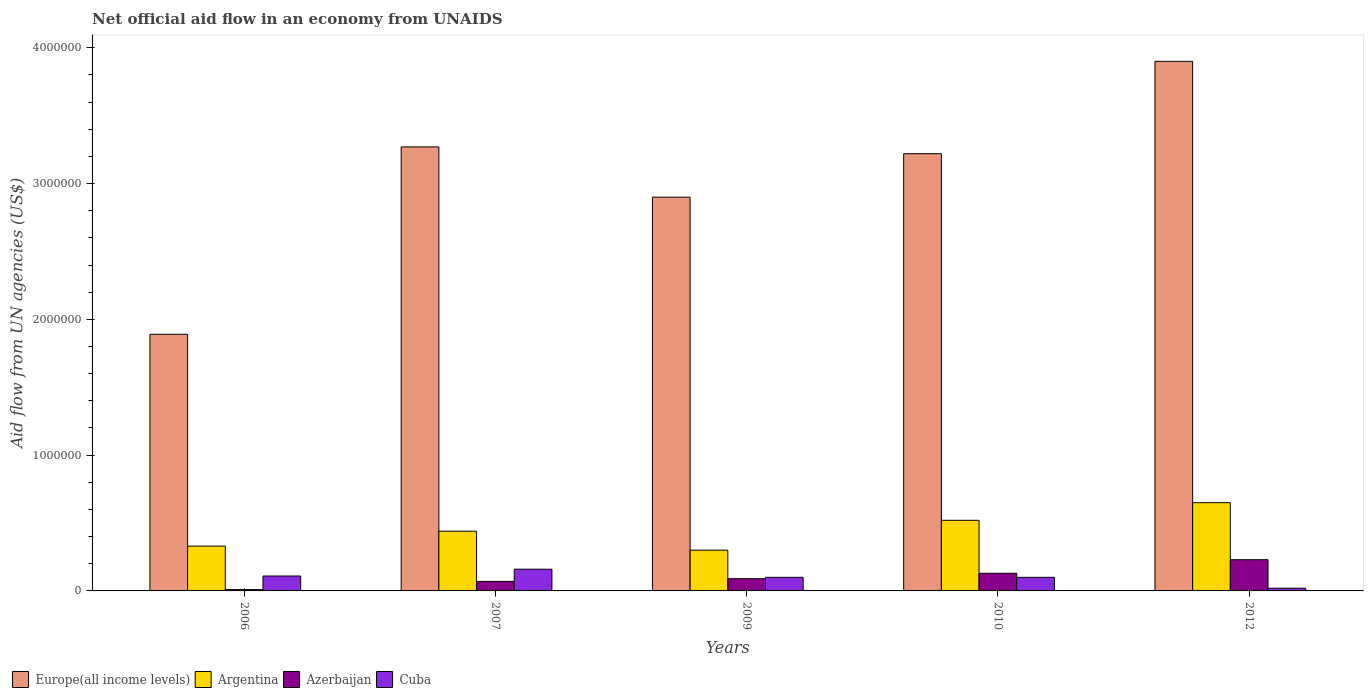How many bars are there on the 1st tick from the left?
Ensure brevity in your answer.  4. What is the net official aid flow in Argentina in 2007?
Ensure brevity in your answer.  4.40e+05. Across all years, what is the maximum net official aid flow in Azerbaijan?
Give a very brief answer. 2.30e+05. What is the total net official aid flow in Argentina in the graph?
Provide a succinct answer. 2.24e+06. What is the difference between the net official aid flow in Cuba in 2006 and that in 2009?
Provide a succinct answer. 10000. What is the difference between the net official aid flow in Argentina in 2009 and the net official aid flow in Europe(all income levels) in 2006?
Make the answer very short. -1.59e+06. What is the average net official aid flow in Cuba per year?
Your response must be concise. 9.80e+04. In the year 2007, what is the difference between the net official aid flow in Argentina and net official aid flow in Europe(all income levels)?
Ensure brevity in your answer.  -2.83e+06. In how many years, is the net official aid flow in Azerbaijan greater than 3400000 US$?
Keep it short and to the point. 0. What is the ratio of the net official aid flow in Azerbaijan in 2007 to that in 2010?
Provide a succinct answer. 0.54. Is the net official aid flow in Cuba in 2006 less than that in 2012?
Make the answer very short. No. Is the difference between the net official aid flow in Argentina in 2009 and 2012 greater than the difference between the net official aid flow in Europe(all income levels) in 2009 and 2012?
Ensure brevity in your answer.  Yes. What is the difference between the highest and the second highest net official aid flow in Azerbaijan?
Provide a short and direct response. 1.00e+05. What is the difference between the highest and the lowest net official aid flow in Europe(all income levels)?
Ensure brevity in your answer.  2.01e+06. Is it the case that in every year, the sum of the net official aid flow in Argentina and net official aid flow in Cuba is greater than the sum of net official aid flow in Europe(all income levels) and net official aid flow in Azerbaijan?
Your answer should be compact. No. What does the 2nd bar from the left in 2009 represents?
Provide a succinct answer. Argentina. What does the 4th bar from the right in 2009 represents?
Make the answer very short. Europe(all income levels). What is the difference between two consecutive major ticks on the Y-axis?
Give a very brief answer. 1.00e+06. How are the legend labels stacked?
Provide a short and direct response. Horizontal. What is the title of the graph?
Make the answer very short. Net official aid flow in an economy from UNAIDS. What is the label or title of the Y-axis?
Provide a short and direct response. Aid flow from UN agencies (US$). What is the Aid flow from UN agencies (US$) of Europe(all income levels) in 2006?
Provide a short and direct response. 1.89e+06. What is the Aid flow from UN agencies (US$) of Argentina in 2006?
Keep it short and to the point. 3.30e+05. What is the Aid flow from UN agencies (US$) of Cuba in 2006?
Ensure brevity in your answer.  1.10e+05. What is the Aid flow from UN agencies (US$) of Europe(all income levels) in 2007?
Your answer should be compact. 3.27e+06. What is the Aid flow from UN agencies (US$) of Argentina in 2007?
Offer a very short reply. 4.40e+05. What is the Aid flow from UN agencies (US$) in Cuba in 2007?
Give a very brief answer. 1.60e+05. What is the Aid flow from UN agencies (US$) of Europe(all income levels) in 2009?
Give a very brief answer. 2.90e+06. What is the Aid flow from UN agencies (US$) in Europe(all income levels) in 2010?
Give a very brief answer. 3.22e+06. What is the Aid flow from UN agencies (US$) in Argentina in 2010?
Provide a succinct answer. 5.20e+05. What is the Aid flow from UN agencies (US$) in Azerbaijan in 2010?
Offer a very short reply. 1.30e+05. What is the Aid flow from UN agencies (US$) of Europe(all income levels) in 2012?
Your answer should be very brief. 3.90e+06. What is the Aid flow from UN agencies (US$) of Argentina in 2012?
Ensure brevity in your answer.  6.50e+05. What is the Aid flow from UN agencies (US$) of Cuba in 2012?
Provide a succinct answer. 2.00e+04. Across all years, what is the maximum Aid flow from UN agencies (US$) in Europe(all income levels)?
Provide a short and direct response. 3.90e+06. Across all years, what is the maximum Aid flow from UN agencies (US$) of Argentina?
Make the answer very short. 6.50e+05. Across all years, what is the maximum Aid flow from UN agencies (US$) of Azerbaijan?
Keep it short and to the point. 2.30e+05. Across all years, what is the minimum Aid flow from UN agencies (US$) in Europe(all income levels)?
Offer a terse response. 1.89e+06. Across all years, what is the minimum Aid flow from UN agencies (US$) in Argentina?
Keep it short and to the point. 3.00e+05. Across all years, what is the minimum Aid flow from UN agencies (US$) of Azerbaijan?
Your answer should be very brief. 10000. Across all years, what is the minimum Aid flow from UN agencies (US$) of Cuba?
Give a very brief answer. 2.00e+04. What is the total Aid flow from UN agencies (US$) in Europe(all income levels) in the graph?
Give a very brief answer. 1.52e+07. What is the total Aid flow from UN agencies (US$) of Argentina in the graph?
Give a very brief answer. 2.24e+06. What is the total Aid flow from UN agencies (US$) in Azerbaijan in the graph?
Provide a short and direct response. 5.30e+05. What is the total Aid flow from UN agencies (US$) of Cuba in the graph?
Ensure brevity in your answer.  4.90e+05. What is the difference between the Aid flow from UN agencies (US$) in Europe(all income levels) in 2006 and that in 2007?
Provide a succinct answer. -1.38e+06. What is the difference between the Aid flow from UN agencies (US$) of Argentina in 2006 and that in 2007?
Provide a short and direct response. -1.10e+05. What is the difference between the Aid flow from UN agencies (US$) of Europe(all income levels) in 2006 and that in 2009?
Give a very brief answer. -1.01e+06. What is the difference between the Aid flow from UN agencies (US$) of Europe(all income levels) in 2006 and that in 2010?
Keep it short and to the point. -1.33e+06. What is the difference between the Aid flow from UN agencies (US$) of Azerbaijan in 2006 and that in 2010?
Your response must be concise. -1.20e+05. What is the difference between the Aid flow from UN agencies (US$) in Cuba in 2006 and that in 2010?
Provide a succinct answer. 10000. What is the difference between the Aid flow from UN agencies (US$) in Europe(all income levels) in 2006 and that in 2012?
Offer a terse response. -2.01e+06. What is the difference between the Aid flow from UN agencies (US$) of Argentina in 2006 and that in 2012?
Your answer should be compact. -3.20e+05. What is the difference between the Aid flow from UN agencies (US$) in Azerbaijan in 2006 and that in 2012?
Keep it short and to the point. -2.20e+05. What is the difference between the Aid flow from UN agencies (US$) of Argentina in 2007 and that in 2009?
Keep it short and to the point. 1.40e+05. What is the difference between the Aid flow from UN agencies (US$) of Europe(all income levels) in 2007 and that in 2010?
Make the answer very short. 5.00e+04. What is the difference between the Aid flow from UN agencies (US$) in Argentina in 2007 and that in 2010?
Offer a very short reply. -8.00e+04. What is the difference between the Aid flow from UN agencies (US$) of Europe(all income levels) in 2007 and that in 2012?
Give a very brief answer. -6.30e+05. What is the difference between the Aid flow from UN agencies (US$) of Argentina in 2007 and that in 2012?
Provide a succinct answer. -2.10e+05. What is the difference between the Aid flow from UN agencies (US$) in Cuba in 2007 and that in 2012?
Your answer should be very brief. 1.40e+05. What is the difference between the Aid flow from UN agencies (US$) in Europe(all income levels) in 2009 and that in 2010?
Your answer should be very brief. -3.20e+05. What is the difference between the Aid flow from UN agencies (US$) of Azerbaijan in 2009 and that in 2010?
Provide a short and direct response. -4.00e+04. What is the difference between the Aid flow from UN agencies (US$) in Cuba in 2009 and that in 2010?
Offer a very short reply. 0. What is the difference between the Aid flow from UN agencies (US$) in Europe(all income levels) in 2009 and that in 2012?
Ensure brevity in your answer.  -1.00e+06. What is the difference between the Aid flow from UN agencies (US$) of Argentina in 2009 and that in 2012?
Offer a very short reply. -3.50e+05. What is the difference between the Aid flow from UN agencies (US$) in Azerbaijan in 2009 and that in 2012?
Ensure brevity in your answer.  -1.40e+05. What is the difference between the Aid flow from UN agencies (US$) in Cuba in 2009 and that in 2012?
Keep it short and to the point. 8.00e+04. What is the difference between the Aid flow from UN agencies (US$) of Europe(all income levels) in 2010 and that in 2012?
Provide a succinct answer. -6.80e+05. What is the difference between the Aid flow from UN agencies (US$) of Argentina in 2010 and that in 2012?
Offer a terse response. -1.30e+05. What is the difference between the Aid flow from UN agencies (US$) in Europe(all income levels) in 2006 and the Aid flow from UN agencies (US$) in Argentina in 2007?
Provide a short and direct response. 1.45e+06. What is the difference between the Aid flow from UN agencies (US$) in Europe(all income levels) in 2006 and the Aid flow from UN agencies (US$) in Azerbaijan in 2007?
Offer a terse response. 1.82e+06. What is the difference between the Aid flow from UN agencies (US$) of Europe(all income levels) in 2006 and the Aid flow from UN agencies (US$) of Cuba in 2007?
Your answer should be very brief. 1.73e+06. What is the difference between the Aid flow from UN agencies (US$) in Europe(all income levels) in 2006 and the Aid flow from UN agencies (US$) in Argentina in 2009?
Give a very brief answer. 1.59e+06. What is the difference between the Aid flow from UN agencies (US$) in Europe(all income levels) in 2006 and the Aid flow from UN agencies (US$) in Azerbaijan in 2009?
Ensure brevity in your answer.  1.80e+06. What is the difference between the Aid flow from UN agencies (US$) of Europe(all income levels) in 2006 and the Aid flow from UN agencies (US$) of Cuba in 2009?
Make the answer very short. 1.79e+06. What is the difference between the Aid flow from UN agencies (US$) of Argentina in 2006 and the Aid flow from UN agencies (US$) of Cuba in 2009?
Offer a very short reply. 2.30e+05. What is the difference between the Aid flow from UN agencies (US$) of Azerbaijan in 2006 and the Aid flow from UN agencies (US$) of Cuba in 2009?
Your answer should be compact. -9.00e+04. What is the difference between the Aid flow from UN agencies (US$) in Europe(all income levels) in 2006 and the Aid flow from UN agencies (US$) in Argentina in 2010?
Ensure brevity in your answer.  1.37e+06. What is the difference between the Aid flow from UN agencies (US$) of Europe(all income levels) in 2006 and the Aid flow from UN agencies (US$) of Azerbaijan in 2010?
Your answer should be compact. 1.76e+06. What is the difference between the Aid flow from UN agencies (US$) in Europe(all income levels) in 2006 and the Aid flow from UN agencies (US$) in Cuba in 2010?
Make the answer very short. 1.79e+06. What is the difference between the Aid flow from UN agencies (US$) in Argentina in 2006 and the Aid flow from UN agencies (US$) in Cuba in 2010?
Provide a succinct answer. 2.30e+05. What is the difference between the Aid flow from UN agencies (US$) of Europe(all income levels) in 2006 and the Aid flow from UN agencies (US$) of Argentina in 2012?
Offer a very short reply. 1.24e+06. What is the difference between the Aid flow from UN agencies (US$) in Europe(all income levels) in 2006 and the Aid flow from UN agencies (US$) in Azerbaijan in 2012?
Ensure brevity in your answer.  1.66e+06. What is the difference between the Aid flow from UN agencies (US$) in Europe(all income levels) in 2006 and the Aid flow from UN agencies (US$) in Cuba in 2012?
Ensure brevity in your answer.  1.87e+06. What is the difference between the Aid flow from UN agencies (US$) in Azerbaijan in 2006 and the Aid flow from UN agencies (US$) in Cuba in 2012?
Your answer should be very brief. -10000. What is the difference between the Aid flow from UN agencies (US$) in Europe(all income levels) in 2007 and the Aid flow from UN agencies (US$) in Argentina in 2009?
Give a very brief answer. 2.97e+06. What is the difference between the Aid flow from UN agencies (US$) of Europe(all income levels) in 2007 and the Aid flow from UN agencies (US$) of Azerbaijan in 2009?
Your response must be concise. 3.18e+06. What is the difference between the Aid flow from UN agencies (US$) of Europe(all income levels) in 2007 and the Aid flow from UN agencies (US$) of Cuba in 2009?
Your response must be concise. 3.17e+06. What is the difference between the Aid flow from UN agencies (US$) of Argentina in 2007 and the Aid flow from UN agencies (US$) of Cuba in 2009?
Offer a very short reply. 3.40e+05. What is the difference between the Aid flow from UN agencies (US$) of Europe(all income levels) in 2007 and the Aid flow from UN agencies (US$) of Argentina in 2010?
Give a very brief answer. 2.75e+06. What is the difference between the Aid flow from UN agencies (US$) of Europe(all income levels) in 2007 and the Aid flow from UN agencies (US$) of Azerbaijan in 2010?
Provide a succinct answer. 3.14e+06. What is the difference between the Aid flow from UN agencies (US$) of Europe(all income levels) in 2007 and the Aid flow from UN agencies (US$) of Cuba in 2010?
Ensure brevity in your answer.  3.17e+06. What is the difference between the Aid flow from UN agencies (US$) in Argentina in 2007 and the Aid flow from UN agencies (US$) in Cuba in 2010?
Offer a terse response. 3.40e+05. What is the difference between the Aid flow from UN agencies (US$) of Europe(all income levels) in 2007 and the Aid flow from UN agencies (US$) of Argentina in 2012?
Provide a succinct answer. 2.62e+06. What is the difference between the Aid flow from UN agencies (US$) in Europe(all income levels) in 2007 and the Aid flow from UN agencies (US$) in Azerbaijan in 2012?
Your answer should be very brief. 3.04e+06. What is the difference between the Aid flow from UN agencies (US$) in Europe(all income levels) in 2007 and the Aid flow from UN agencies (US$) in Cuba in 2012?
Keep it short and to the point. 3.25e+06. What is the difference between the Aid flow from UN agencies (US$) in Azerbaijan in 2007 and the Aid flow from UN agencies (US$) in Cuba in 2012?
Make the answer very short. 5.00e+04. What is the difference between the Aid flow from UN agencies (US$) of Europe(all income levels) in 2009 and the Aid flow from UN agencies (US$) of Argentina in 2010?
Your response must be concise. 2.38e+06. What is the difference between the Aid flow from UN agencies (US$) of Europe(all income levels) in 2009 and the Aid flow from UN agencies (US$) of Azerbaijan in 2010?
Provide a succinct answer. 2.77e+06. What is the difference between the Aid flow from UN agencies (US$) in Europe(all income levels) in 2009 and the Aid flow from UN agencies (US$) in Cuba in 2010?
Offer a terse response. 2.80e+06. What is the difference between the Aid flow from UN agencies (US$) of Argentina in 2009 and the Aid flow from UN agencies (US$) of Azerbaijan in 2010?
Give a very brief answer. 1.70e+05. What is the difference between the Aid flow from UN agencies (US$) in Europe(all income levels) in 2009 and the Aid flow from UN agencies (US$) in Argentina in 2012?
Offer a terse response. 2.25e+06. What is the difference between the Aid flow from UN agencies (US$) in Europe(all income levels) in 2009 and the Aid flow from UN agencies (US$) in Azerbaijan in 2012?
Provide a short and direct response. 2.67e+06. What is the difference between the Aid flow from UN agencies (US$) in Europe(all income levels) in 2009 and the Aid flow from UN agencies (US$) in Cuba in 2012?
Offer a very short reply. 2.88e+06. What is the difference between the Aid flow from UN agencies (US$) in Argentina in 2009 and the Aid flow from UN agencies (US$) in Azerbaijan in 2012?
Keep it short and to the point. 7.00e+04. What is the difference between the Aid flow from UN agencies (US$) of Azerbaijan in 2009 and the Aid flow from UN agencies (US$) of Cuba in 2012?
Give a very brief answer. 7.00e+04. What is the difference between the Aid flow from UN agencies (US$) in Europe(all income levels) in 2010 and the Aid flow from UN agencies (US$) in Argentina in 2012?
Make the answer very short. 2.57e+06. What is the difference between the Aid flow from UN agencies (US$) in Europe(all income levels) in 2010 and the Aid flow from UN agencies (US$) in Azerbaijan in 2012?
Your answer should be very brief. 2.99e+06. What is the difference between the Aid flow from UN agencies (US$) in Europe(all income levels) in 2010 and the Aid flow from UN agencies (US$) in Cuba in 2012?
Give a very brief answer. 3.20e+06. What is the average Aid flow from UN agencies (US$) in Europe(all income levels) per year?
Your answer should be very brief. 3.04e+06. What is the average Aid flow from UN agencies (US$) in Argentina per year?
Provide a short and direct response. 4.48e+05. What is the average Aid flow from UN agencies (US$) of Azerbaijan per year?
Provide a succinct answer. 1.06e+05. What is the average Aid flow from UN agencies (US$) in Cuba per year?
Provide a succinct answer. 9.80e+04. In the year 2006, what is the difference between the Aid flow from UN agencies (US$) in Europe(all income levels) and Aid flow from UN agencies (US$) in Argentina?
Provide a short and direct response. 1.56e+06. In the year 2006, what is the difference between the Aid flow from UN agencies (US$) in Europe(all income levels) and Aid flow from UN agencies (US$) in Azerbaijan?
Your answer should be very brief. 1.88e+06. In the year 2006, what is the difference between the Aid flow from UN agencies (US$) in Europe(all income levels) and Aid flow from UN agencies (US$) in Cuba?
Provide a succinct answer. 1.78e+06. In the year 2006, what is the difference between the Aid flow from UN agencies (US$) of Argentina and Aid flow from UN agencies (US$) of Cuba?
Offer a very short reply. 2.20e+05. In the year 2006, what is the difference between the Aid flow from UN agencies (US$) of Azerbaijan and Aid flow from UN agencies (US$) of Cuba?
Offer a terse response. -1.00e+05. In the year 2007, what is the difference between the Aid flow from UN agencies (US$) in Europe(all income levels) and Aid flow from UN agencies (US$) in Argentina?
Make the answer very short. 2.83e+06. In the year 2007, what is the difference between the Aid flow from UN agencies (US$) in Europe(all income levels) and Aid flow from UN agencies (US$) in Azerbaijan?
Provide a succinct answer. 3.20e+06. In the year 2007, what is the difference between the Aid flow from UN agencies (US$) in Europe(all income levels) and Aid flow from UN agencies (US$) in Cuba?
Your answer should be compact. 3.11e+06. In the year 2007, what is the difference between the Aid flow from UN agencies (US$) in Argentina and Aid flow from UN agencies (US$) in Azerbaijan?
Give a very brief answer. 3.70e+05. In the year 2007, what is the difference between the Aid flow from UN agencies (US$) of Azerbaijan and Aid flow from UN agencies (US$) of Cuba?
Offer a very short reply. -9.00e+04. In the year 2009, what is the difference between the Aid flow from UN agencies (US$) of Europe(all income levels) and Aid flow from UN agencies (US$) of Argentina?
Make the answer very short. 2.60e+06. In the year 2009, what is the difference between the Aid flow from UN agencies (US$) in Europe(all income levels) and Aid flow from UN agencies (US$) in Azerbaijan?
Keep it short and to the point. 2.81e+06. In the year 2009, what is the difference between the Aid flow from UN agencies (US$) in Europe(all income levels) and Aid flow from UN agencies (US$) in Cuba?
Ensure brevity in your answer.  2.80e+06. In the year 2010, what is the difference between the Aid flow from UN agencies (US$) in Europe(all income levels) and Aid flow from UN agencies (US$) in Argentina?
Your answer should be very brief. 2.70e+06. In the year 2010, what is the difference between the Aid flow from UN agencies (US$) of Europe(all income levels) and Aid flow from UN agencies (US$) of Azerbaijan?
Provide a short and direct response. 3.09e+06. In the year 2010, what is the difference between the Aid flow from UN agencies (US$) in Europe(all income levels) and Aid flow from UN agencies (US$) in Cuba?
Your answer should be very brief. 3.12e+06. In the year 2010, what is the difference between the Aid flow from UN agencies (US$) in Argentina and Aid flow from UN agencies (US$) in Azerbaijan?
Your answer should be compact. 3.90e+05. In the year 2010, what is the difference between the Aid flow from UN agencies (US$) of Azerbaijan and Aid flow from UN agencies (US$) of Cuba?
Offer a very short reply. 3.00e+04. In the year 2012, what is the difference between the Aid flow from UN agencies (US$) in Europe(all income levels) and Aid flow from UN agencies (US$) in Argentina?
Ensure brevity in your answer.  3.25e+06. In the year 2012, what is the difference between the Aid flow from UN agencies (US$) in Europe(all income levels) and Aid flow from UN agencies (US$) in Azerbaijan?
Give a very brief answer. 3.67e+06. In the year 2012, what is the difference between the Aid flow from UN agencies (US$) in Europe(all income levels) and Aid flow from UN agencies (US$) in Cuba?
Your answer should be compact. 3.88e+06. In the year 2012, what is the difference between the Aid flow from UN agencies (US$) of Argentina and Aid flow from UN agencies (US$) of Cuba?
Provide a short and direct response. 6.30e+05. What is the ratio of the Aid flow from UN agencies (US$) of Europe(all income levels) in 2006 to that in 2007?
Your answer should be compact. 0.58. What is the ratio of the Aid flow from UN agencies (US$) in Argentina in 2006 to that in 2007?
Offer a very short reply. 0.75. What is the ratio of the Aid flow from UN agencies (US$) in Azerbaijan in 2006 to that in 2007?
Make the answer very short. 0.14. What is the ratio of the Aid flow from UN agencies (US$) in Cuba in 2006 to that in 2007?
Provide a succinct answer. 0.69. What is the ratio of the Aid flow from UN agencies (US$) of Europe(all income levels) in 2006 to that in 2009?
Provide a succinct answer. 0.65. What is the ratio of the Aid flow from UN agencies (US$) of Argentina in 2006 to that in 2009?
Provide a succinct answer. 1.1. What is the ratio of the Aid flow from UN agencies (US$) of Europe(all income levels) in 2006 to that in 2010?
Provide a succinct answer. 0.59. What is the ratio of the Aid flow from UN agencies (US$) of Argentina in 2006 to that in 2010?
Keep it short and to the point. 0.63. What is the ratio of the Aid flow from UN agencies (US$) in Azerbaijan in 2006 to that in 2010?
Give a very brief answer. 0.08. What is the ratio of the Aid flow from UN agencies (US$) in Europe(all income levels) in 2006 to that in 2012?
Give a very brief answer. 0.48. What is the ratio of the Aid flow from UN agencies (US$) in Argentina in 2006 to that in 2012?
Your answer should be compact. 0.51. What is the ratio of the Aid flow from UN agencies (US$) in Azerbaijan in 2006 to that in 2012?
Make the answer very short. 0.04. What is the ratio of the Aid flow from UN agencies (US$) in Cuba in 2006 to that in 2012?
Keep it short and to the point. 5.5. What is the ratio of the Aid flow from UN agencies (US$) in Europe(all income levels) in 2007 to that in 2009?
Provide a succinct answer. 1.13. What is the ratio of the Aid flow from UN agencies (US$) of Argentina in 2007 to that in 2009?
Give a very brief answer. 1.47. What is the ratio of the Aid flow from UN agencies (US$) of Azerbaijan in 2007 to that in 2009?
Make the answer very short. 0.78. What is the ratio of the Aid flow from UN agencies (US$) of Europe(all income levels) in 2007 to that in 2010?
Keep it short and to the point. 1.02. What is the ratio of the Aid flow from UN agencies (US$) in Argentina in 2007 to that in 2010?
Offer a very short reply. 0.85. What is the ratio of the Aid flow from UN agencies (US$) of Azerbaijan in 2007 to that in 2010?
Ensure brevity in your answer.  0.54. What is the ratio of the Aid flow from UN agencies (US$) in Cuba in 2007 to that in 2010?
Offer a terse response. 1.6. What is the ratio of the Aid flow from UN agencies (US$) of Europe(all income levels) in 2007 to that in 2012?
Ensure brevity in your answer.  0.84. What is the ratio of the Aid flow from UN agencies (US$) in Argentina in 2007 to that in 2012?
Make the answer very short. 0.68. What is the ratio of the Aid flow from UN agencies (US$) of Azerbaijan in 2007 to that in 2012?
Your response must be concise. 0.3. What is the ratio of the Aid flow from UN agencies (US$) of Cuba in 2007 to that in 2012?
Make the answer very short. 8. What is the ratio of the Aid flow from UN agencies (US$) of Europe(all income levels) in 2009 to that in 2010?
Offer a very short reply. 0.9. What is the ratio of the Aid flow from UN agencies (US$) in Argentina in 2009 to that in 2010?
Your answer should be compact. 0.58. What is the ratio of the Aid flow from UN agencies (US$) in Azerbaijan in 2009 to that in 2010?
Offer a terse response. 0.69. What is the ratio of the Aid flow from UN agencies (US$) of Europe(all income levels) in 2009 to that in 2012?
Your response must be concise. 0.74. What is the ratio of the Aid flow from UN agencies (US$) in Argentina in 2009 to that in 2012?
Ensure brevity in your answer.  0.46. What is the ratio of the Aid flow from UN agencies (US$) of Azerbaijan in 2009 to that in 2012?
Give a very brief answer. 0.39. What is the ratio of the Aid flow from UN agencies (US$) of Europe(all income levels) in 2010 to that in 2012?
Give a very brief answer. 0.83. What is the ratio of the Aid flow from UN agencies (US$) of Argentina in 2010 to that in 2012?
Give a very brief answer. 0.8. What is the ratio of the Aid flow from UN agencies (US$) of Azerbaijan in 2010 to that in 2012?
Your response must be concise. 0.57. What is the difference between the highest and the second highest Aid flow from UN agencies (US$) of Europe(all income levels)?
Your response must be concise. 6.30e+05. What is the difference between the highest and the second highest Aid flow from UN agencies (US$) of Azerbaijan?
Your answer should be very brief. 1.00e+05. What is the difference between the highest and the second highest Aid flow from UN agencies (US$) of Cuba?
Offer a very short reply. 5.00e+04. What is the difference between the highest and the lowest Aid flow from UN agencies (US$) of Europe(all income levels)?
Offer a very short reply. 2.01e+06. What is the difference between the highest and the lowest Aid flow from UN agencies (US$) in Argentina?
Offer a terse response. 3.50e+05. 